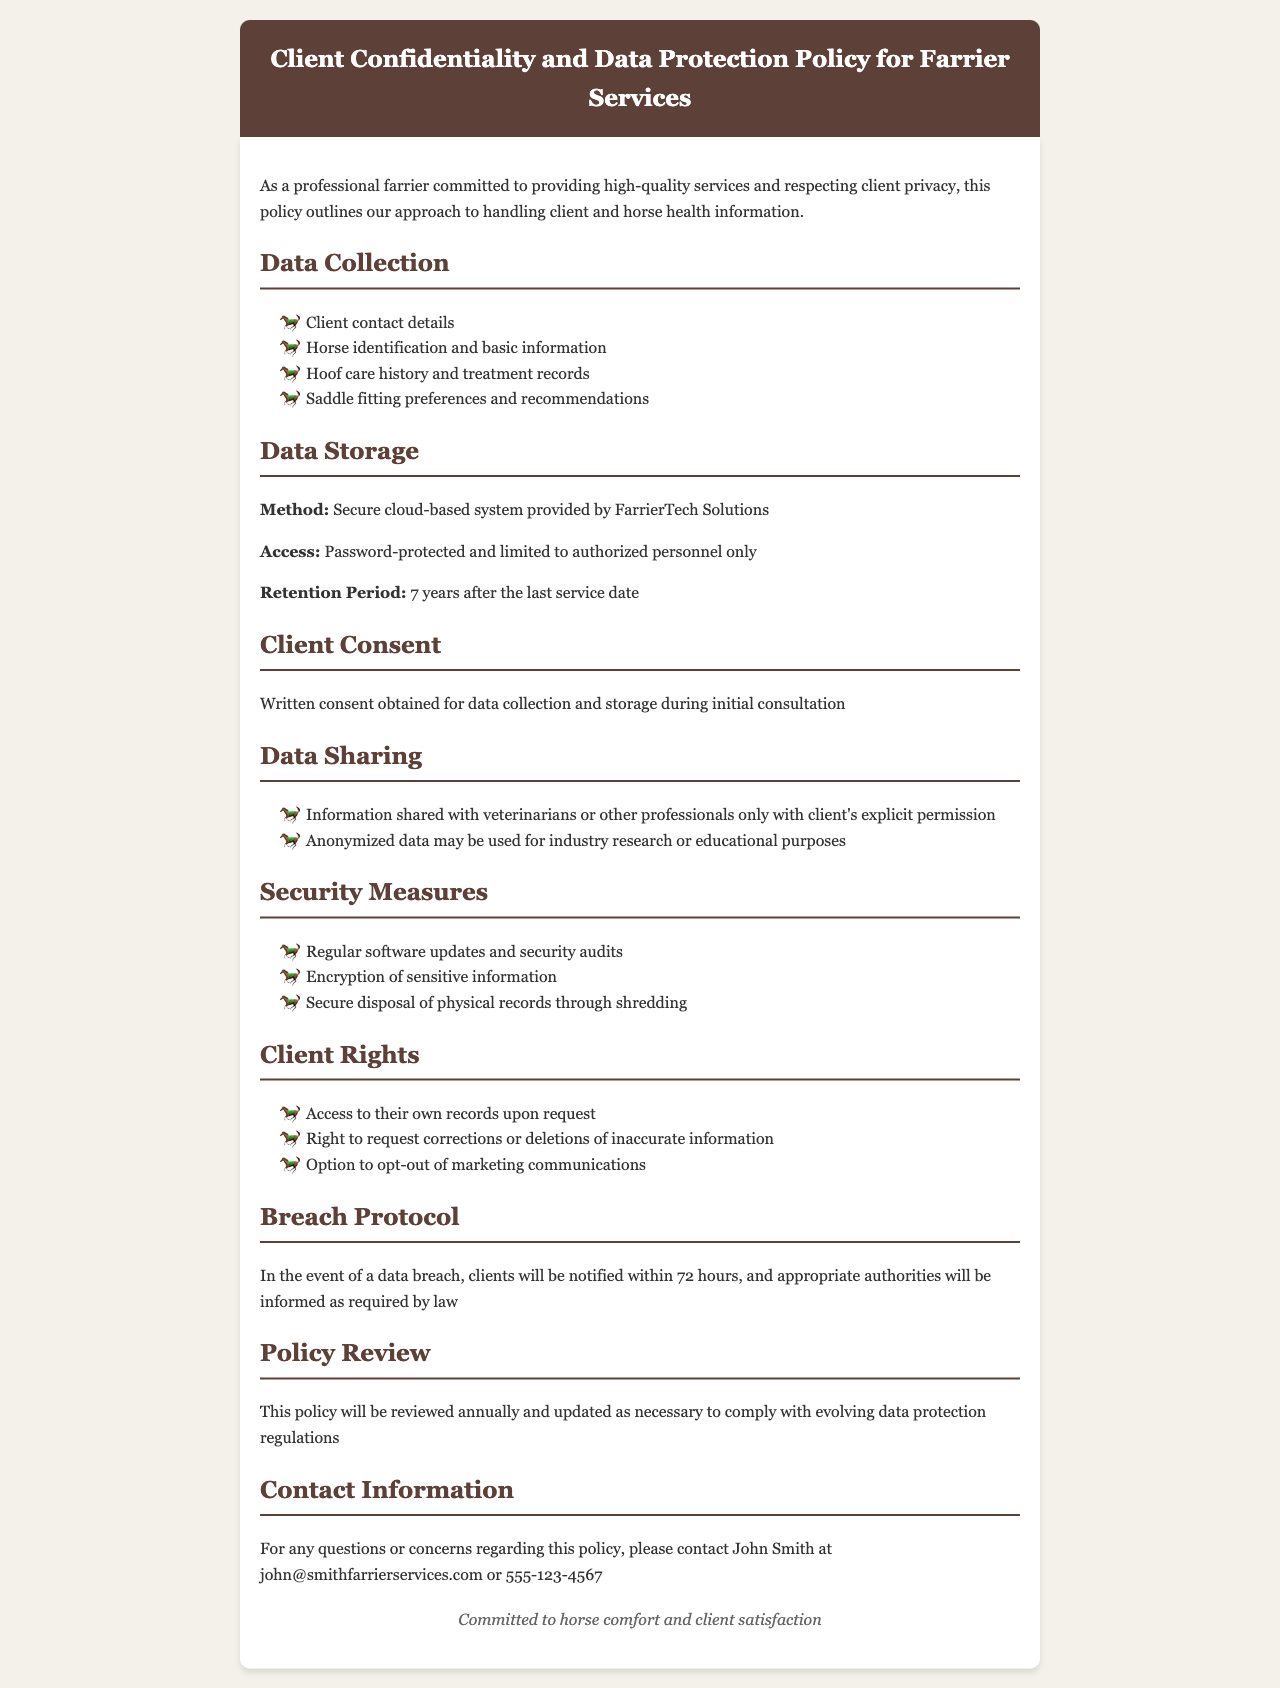What is the method of data storage? The method of data storage is a secure cloud-based system provided by FarrierTech Solutions.
Answer: Secure cloud-based system provided by FarrierTech Solutions What is the retention period for records? The retention period for records is specified in the document to be 7 years after the last service date.
Answer: 7 years after the last service date Who can access the stored data? The document mentions that data access is limited to authorized personnel only, ensuring confidentiality.
Answer: Authorized personnel only What type of consent is obtained for data collection? The type of consent obtained for data collection is indicated as written consent during the initial consultation.
Answer: Written consent How soon will clients be notified of a data breach? The document states that clients will be notified within 72 hours in the event of a data breach.
Answer: 72 hours What type of information might be shared with veterinarians? The document specifies that information can be shared with veterinarians only with the client's explicit permission.
Answer: Client's explicit permission What is the policy review frequency? The document outlines that the policy will be reviewed annually to ensure compliance with regulations.
Answer: Annually What actions can clients take regarding inaccurate information? Clients have the right to request corrections or deletions of inaccurate information as stated in the document.
Answer: Request corrections or deletions What is the primary commitment mentioned in the footer? The footer highlights a commitment that is central to the farrier's practice, emphasizing their dedication.
Answer: Horse comfort and client satisfaction 